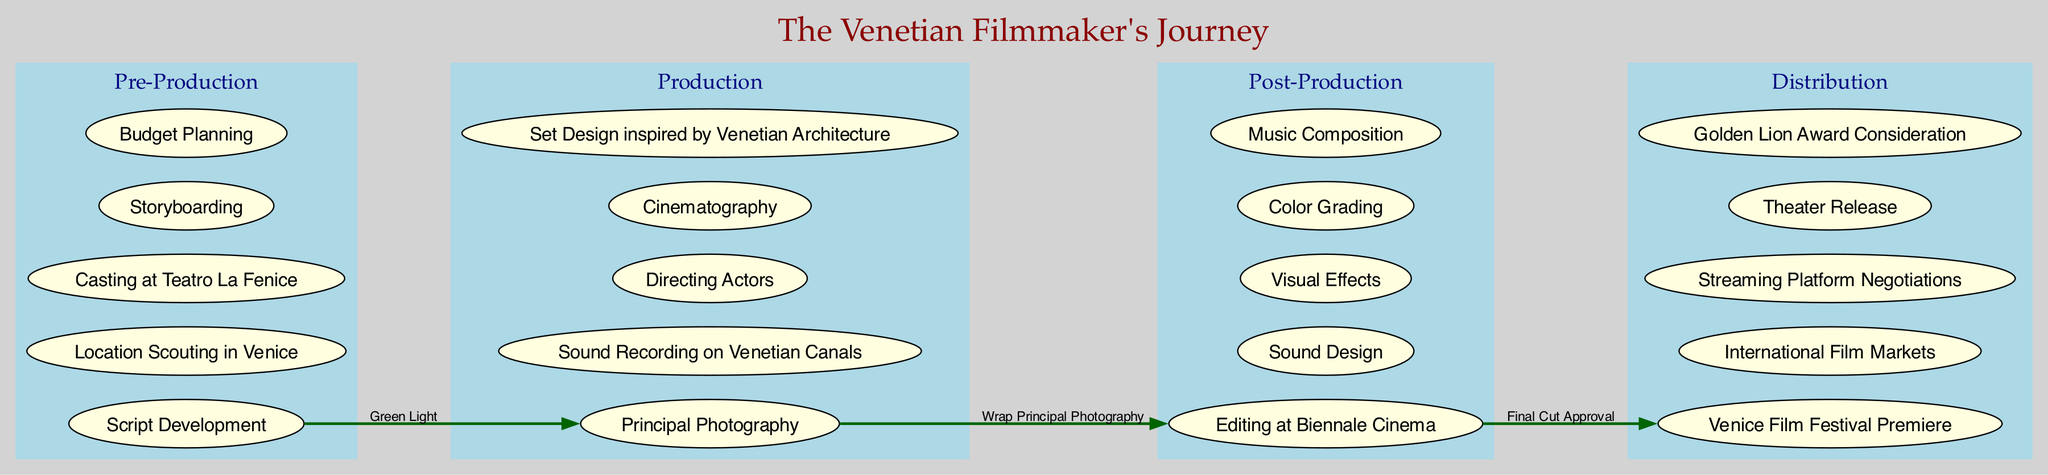What are the stages of the filmmaking process depicted in the diagram? The diagram lists four stages: Pre-Production, Production, Post-Production, and Distribution. This information can be found in the clusters representing each stage.
Answer: Pre-Production, Production, Post-Production, Distribution How many elements are in the Production stage? In the Production stage, there are five specific elements mentioned: Principal Photography, Sound Recording on Venetian Canals, Directing Actors, Cinematography, and Set Design inspired by Venetian Architecture.
Answer: 5 What is the connection from Pre-Production to Production labeled as? The diagram indicates that the transition from Pre-Production to Production is labeled "Green Light." This label is listed on the connecting edge between these two stages.
Answer: Green Light Which element in the Post-Production stage involves creating sounds? The diagram specifies "Sound Design" as one of the elements in the Post-Production stage that involves creating sounds, found in the list of elements within that cluster.
Answer: Sound Design What is the last stage of the filmmaking process shown in the diagram? The final stage shown in the diagram is Distribution, which can be identified as the last cluster that appears in the flow of the stages.
Answer: Distribution Which stage does the connection "Wrap Principal Photography" lead to? The label "Wrap Principal Photography" indicates a transition from Production to the next stage, which is Post-Production. This can be inferred from the directional edge in the diagram.
Answer: Post-Production How many connections are there in total between the stages? There are three connections illustrated in the diagram, each linking one stage to the next in the filmmaking process. This number can be counted from the edges shown connecting the different clusters.
Answer: 3 What is the significance of the Venice Film Festival in the Distribution stage? The diagram mentions the Venice Film Festival Premiere as an important element in the Distribution stage, indicating its significance for the distribution of films. This can be recognized as part of the festival-centric distribution strategy.
Answer: Venice Film Festival Premiere 